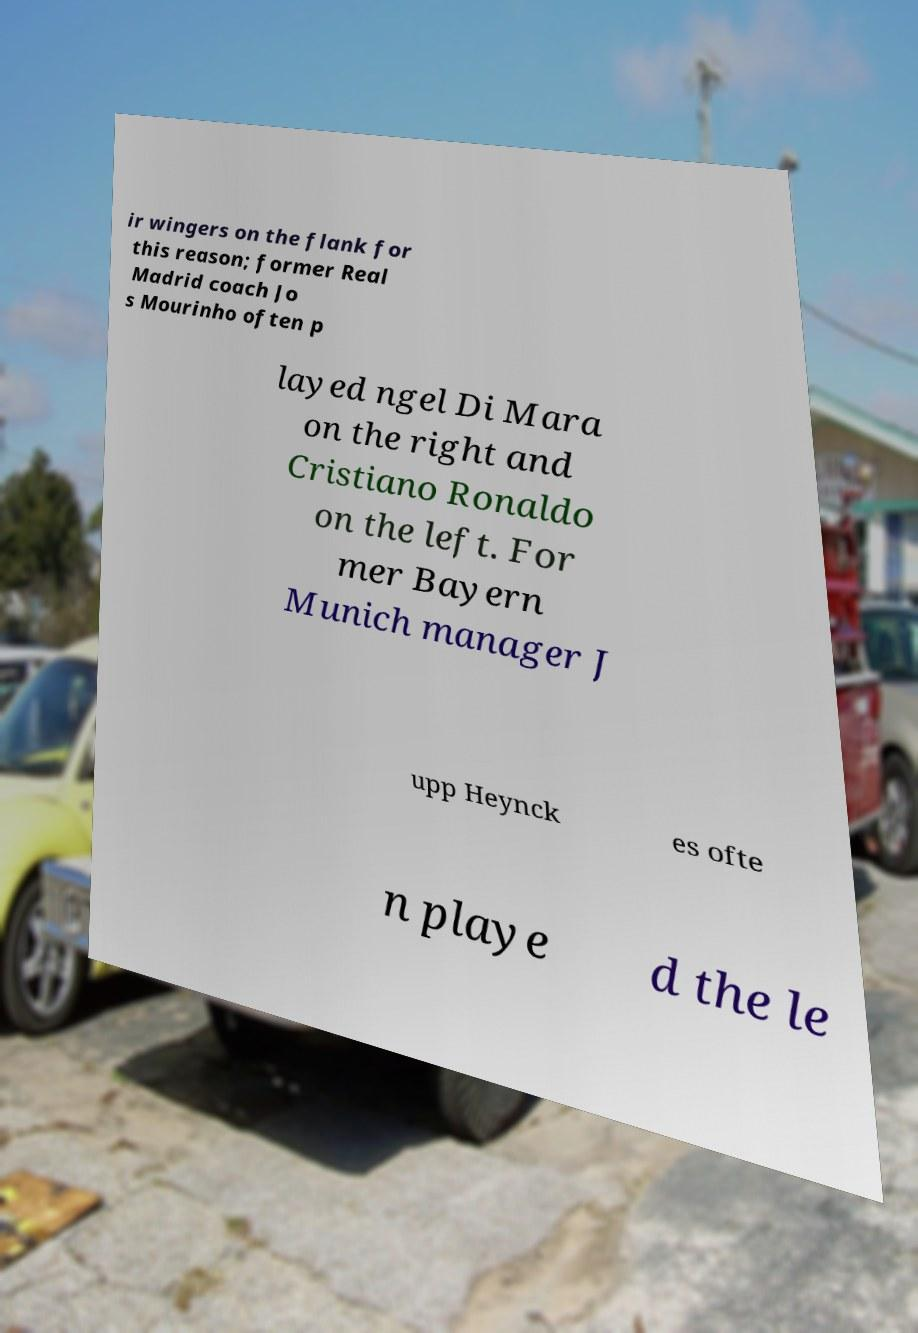I need the written content from this picture converted into text. Can you do that? ir wingers on the flank for this reason; former Real Madrid coach Jo s Mourinho often p layed ngel Di Mara on the right and Cristiano Ronaldo on the left. For mer Bayern Munich manager J upp Heynck es ofte n playe d the le 